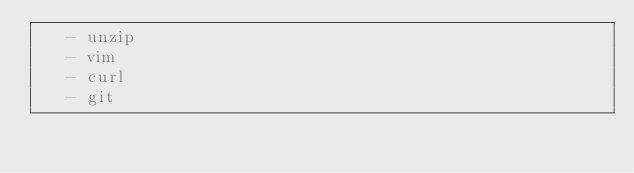<code> <loc_0><loc_0><loc_500><loc_500><_YAML_>   - unzip
   - vim
   - curl
   - git
</code> 